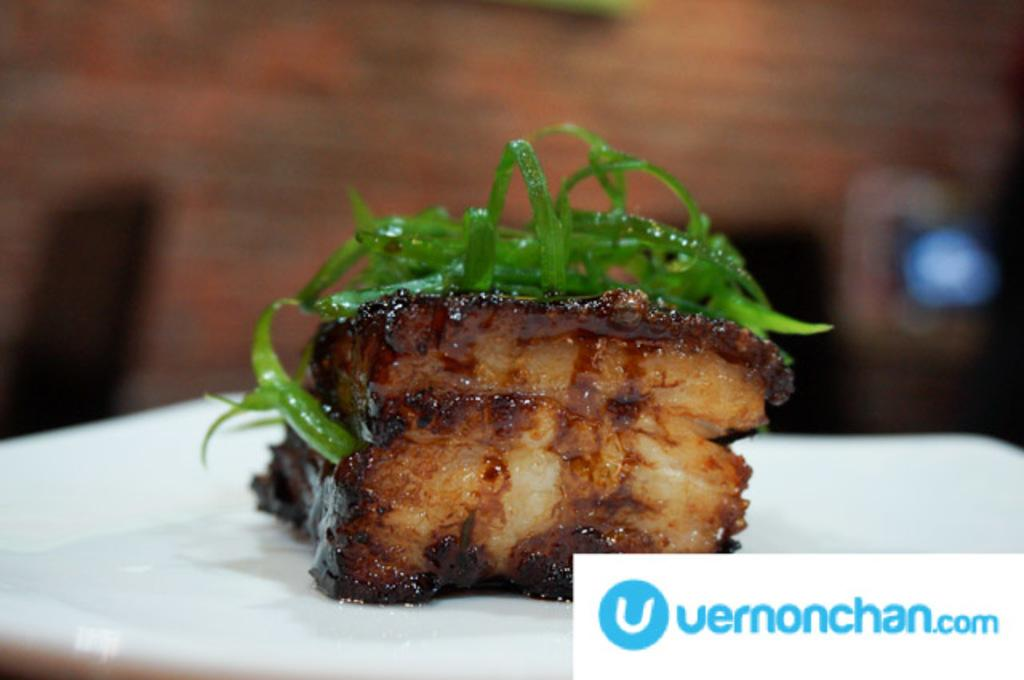What is on the plate in the image? There is food on a plate in the image. What else is on the plate besides the food? There are leaves on the plate. Can you describe the background of the image? The background of the image is blurry. What can be seen in the bottom right corner of the image? There is text visible in the bottom right corner of the image. What type of rhythm is being played by the twig in the image? There is no twig or rhythm present in the image. 